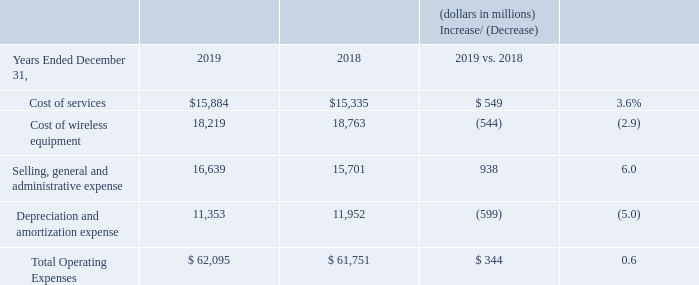Operating Expenses
Cost of Services Cost of services increased $549 million, or 3.6%, during 2019 compared to 2018, primarily due to increases in rent expense as a result of adding capacity to the networks to support demand as well as an increase due to the adoption of the new lease accounting standard in 2019, increases in costs related to the device protection package offered to our wireless retail postpaid customers, as well as regulatory fees.
These increases were partially offset by decreases in employee-related costs primarily due to the Voluntary Separation Program, as well as decreases in access costs and roaming.
Cost of Wireless Equipment Cost of wireless equipment decreased $544 million, or 2.9%, during 2019 compared to 2018, primarily as a result of declines in the number of wireless devices sold as a result of an elongation of the handset upgrade cycle. These decrease were partially offset by a shift to higher priced devices in the mix of wireless devices sold.
Selling, General and Administrative Expense Selling, general and administrative expense increased $938 million, or 6.0%, during 2019 compared to 2018, primarily due to increases in sales commission and bad debt expense, and an increase in advertising costs. The increase in sales commission expense during 2019 compared to 2018 was primarily due to a lower net deferral of commission costs as a result of the adoption of Topic 606 on January 1, 2018 using a modified retrospective approach.
These increases were partially offset by decreases in employee-related costs primarily due to the Voluntary Separation Program.
Depreciation and Amortization Expense Depreciation and amortization expense decreased $599 million, or 5.0%, during 2019 compared to 2018, driven by the change in the mix of total Verizon depreciable assets and Consumer’s usage of those assets.
How much did Cost of services increase in 2019? $549 million. What is the total operating expenses in 2019?
Answer scale should be: million. $ 62,095. How much did Cost of wireless equipment decrease in 2019? $544 million. What is the change in Cost of services from 2018 to 2019?
Answer scale should be: million. 15,884-15,335
Answer: 549. What is the change in Cost of wireless equipment from 2018 to 2019?
Answer scale should be: million. 18,219-18,763
Answer: -544. What is the change in Total Operating Expenses from 2018 to 2019?
Answer scale should be: million. 62,095-61,751
Answer: 344. 